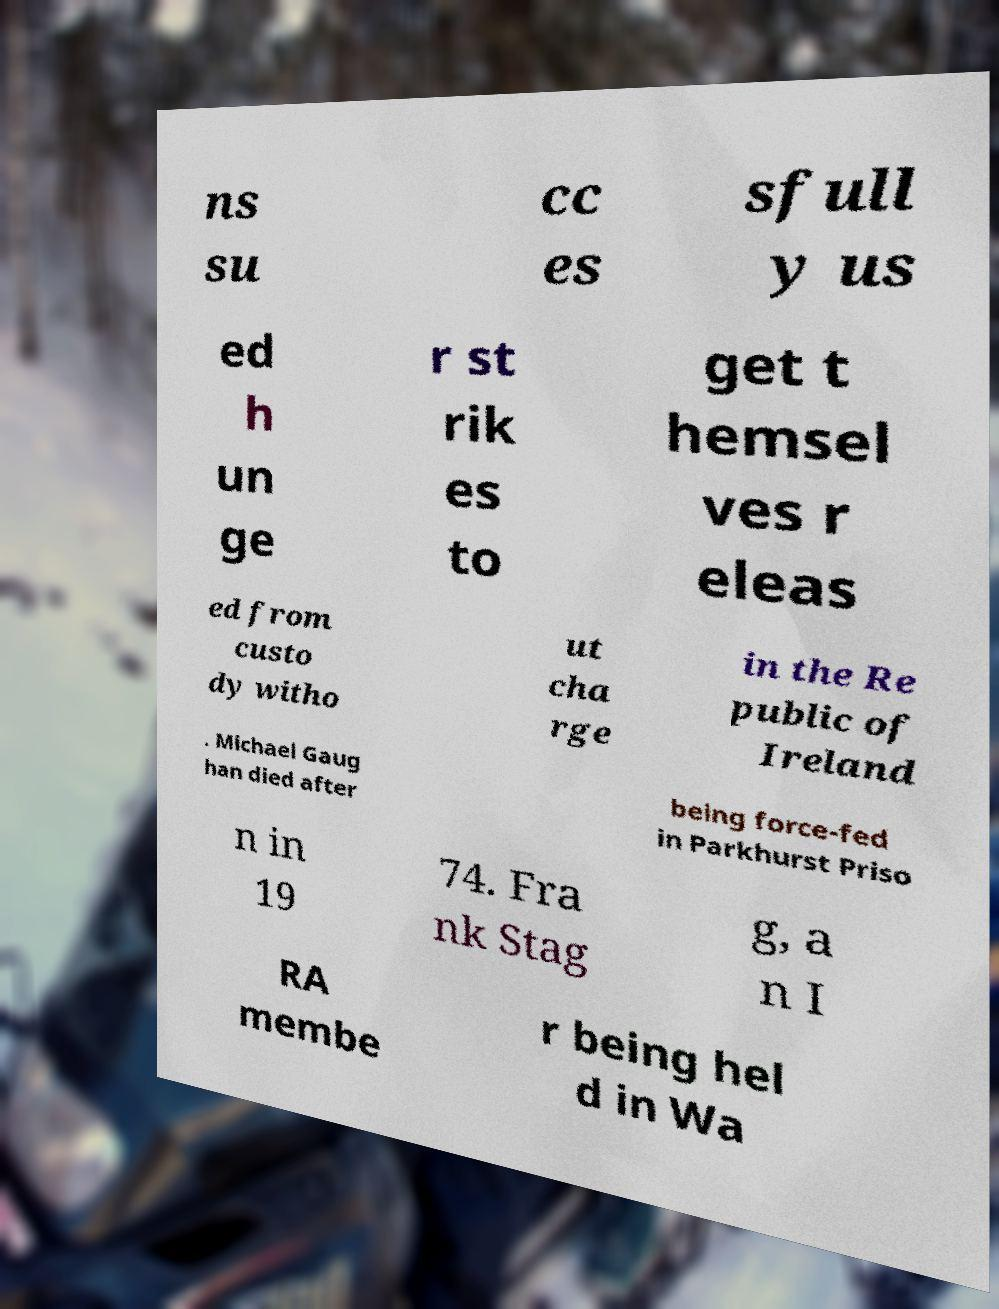Could you extract and type out the text from this image? ns su cc es sfull y us ed h un ge r st rik es to get t hemsel ves r eleas ed from custo dy witho ut cha rge in the Re public of Ireland . Michael Gaug han died after being force-fed in Parkhurst Priso n in 19 74. Fra nk Stag g, a n I RA membe r being hel d in Wa 